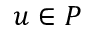<formula> <loc_0><loc_0><loc_500><loc_500>u \in P</formula> 